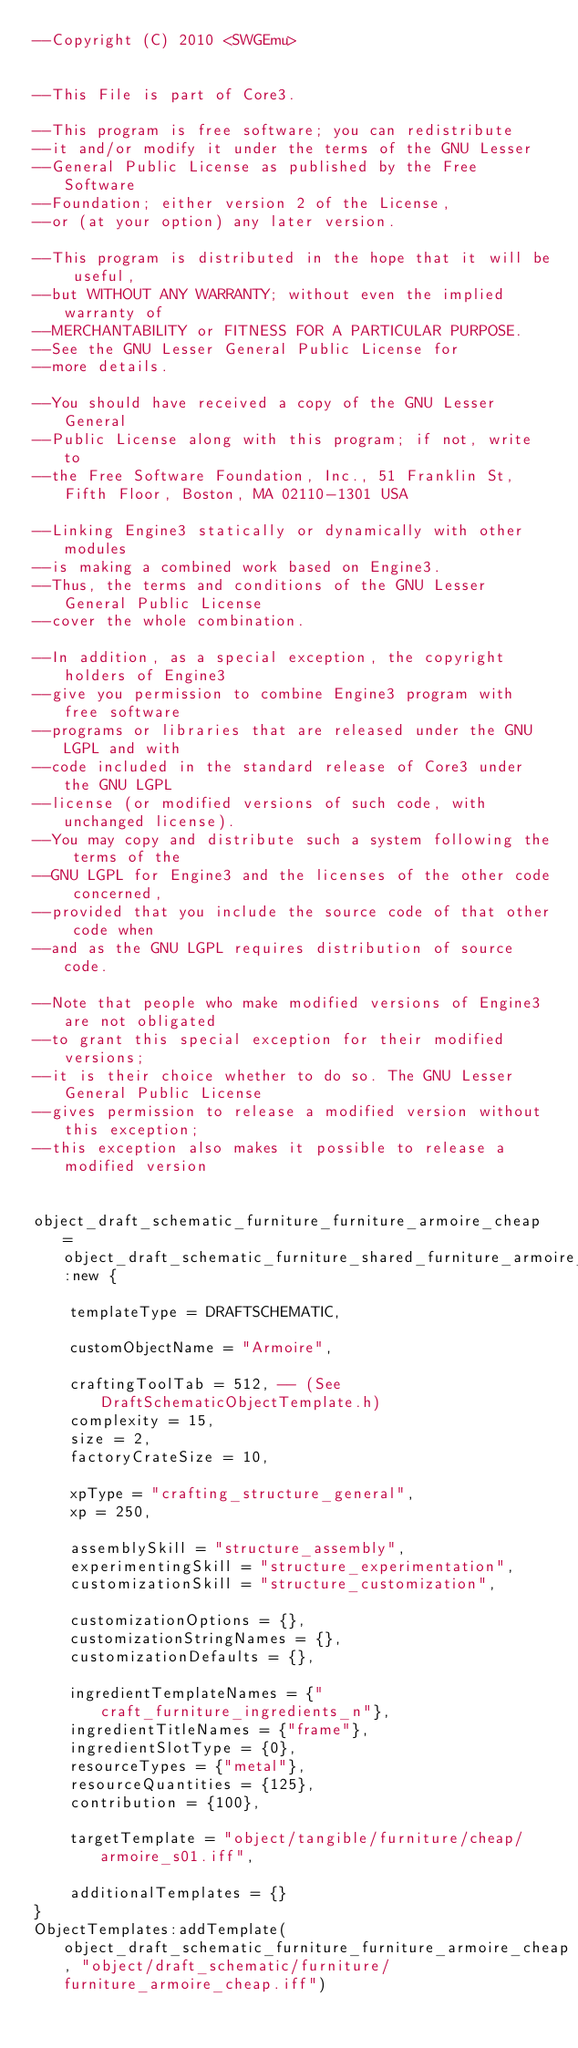<code> <loc_0><loc_0><loc_500><loc_500><_Lua_>--Copyright (C) 2010 <SWGEmu>


--This File is part of Core3.

--This program is free software; you can redistribute 
--it and/or modify it under the terms of the GNU Lesser 
--General Public License as published by the Free Software
--Foundation; either version 2 of the License, 
--or (at your option) any later version.

--This program is distributed in the hope that it will be useful, 
--but WITHOUT ANY WARRANTY; without even the implied warranty of 
--MERCHANTABILITY or FITNESS FOR A PARTICULAR PURPOSE. 
--See the GNU Lesser General Public License for
--more details.

--You should have received a copy of the GNU Lesser General 
--Public License along with this program; if not, write to
--the Free Software Foundation, Inc., 51 Franklin St, Fifth Floor, Boston, MA 02110-1301 USA

--Linking Engine3 statically or dynamically with other modules 
--is making a combined work based on Engine3. 
--Thus, the terms and conditions of the GNU Lesser General Public License 
--cover the whole combination.

--In addition, as a special exception, the copyright holders of Engine3 
--give you permission to combine Engine3 program with free software 
--programs or libraries that are released under the GNU LGPL and with 
--code included in the standard release of Core3 under the GNU LGPL 
--license (or modified versions of such code, with unchanged license). 
--You may copy and distribute such a system following the terms of the 
--GNU LGPL for Engine3 and the licenses of the other code concerned, 
--provided that you include the source code of that other code when 
--and as the GNU LGPL requires distribution of source code.

--Note that people who make modified versions of Engine3 are not obligated 
--to grant this special exception for their modified versions; 
--it is their choice whether to do so. The GNU Lesser General Public License 
--gives permission to release a modified version without this exception; 
--this exception also makes it possible to release a modified version 


object_draft_schematic_furniture_furniture_armoire_cheap = object_draft_schematic_furniture_shared_furniture_armoire_cheap:new {

	templateType = DRAFTSCHEMATIC,

	customObjectName = "Armoire",

	craftingToolTab = 512, -- (See DraftSchematicObjectTemplate.h)
	complexity = 15,
	size = 2,
	factoryCrateSize = 10,

	xpType = "crafting_structure_general",
	xp = 250,

	assemblySkill = "structure_assembly",
	experimentingSkill = "structure_experimentation",
	customizationSkill = "structure_customization",

	customizationOptions = {},
	customizationStringNames = {},
	customizationDefaults = {},

	ingredientTemplateNames = {"craft_furniture_ingredients_n"},
	ingredientTitleNames = {"frame"},
	ingredientSlotType = {0},
	resourceTypes = {"metal"},
	resourceQuantities = {125},
	contribution = {100},

	targetTemplate = "object/tangible/furniture/cheap/armoire_s01.iff",

	additionalTemplates = {}
}
ObjectTemplates:addTemplate(object_draft_schematic_furniture_furniture_armoire_cheap, "object/draft_schematic/furniture/furniture_armoire_cheap.iff")
</code> 